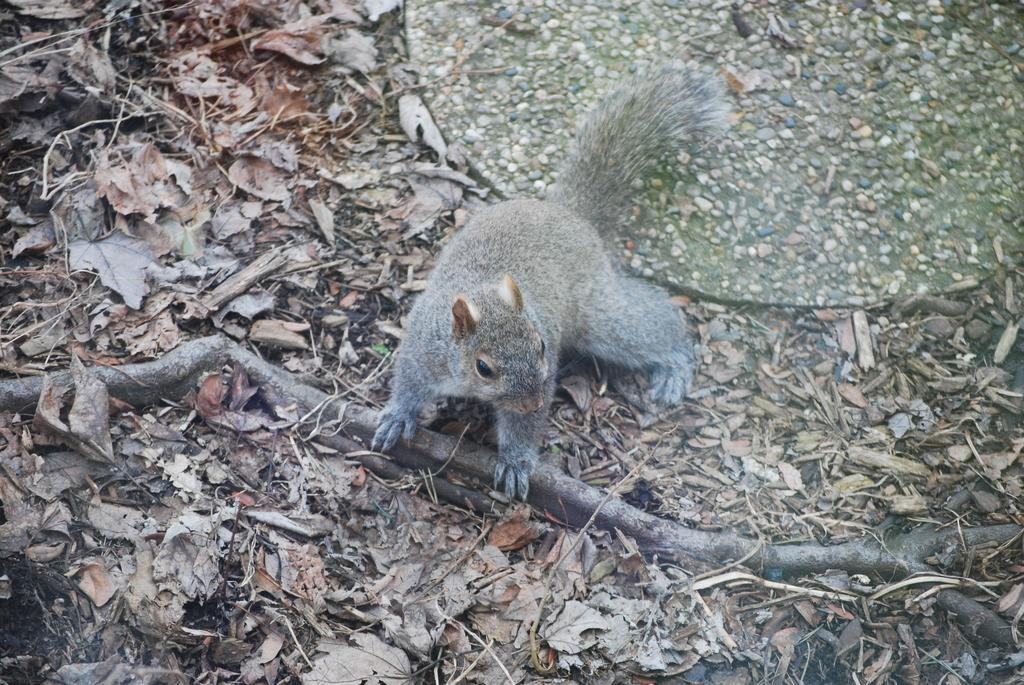What animal can be seen in the picture? There is a squirrel in the picture. What is the squirrel holding in its paws? The squirrel is holding a wooden stick. What can be seen on the ground around the squirrel? There are dried leaves on either side of the squirrel. What historical event is being commemorated by the squirrel in the picture? There is no indication of any historical event being commemorated in the image; it simply features a squirrel holding a wooden stick and surrounded by dried leaves. 